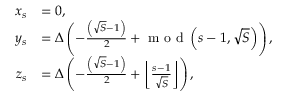<formula> <loc_0><loc_0><loc_500><loc_500>\begin{array} { r l } { x _ { s } } & { = 0 , } \\ { y _ { s } } & { = \Delta \left ( - \frac { \left ( \sqrt { S } - 1 \right ) } { 2 } + m o d \left ( s - 1 , \sqrt { S } \right ) \right ) , } \\ { z _ { s } } & { = \Delta \left ( - \frac { \left ( \sqrt { S } - 1 \right ) } { 2 } + \left \lfloor \frac { s - 1 } { \sqrt { S } } \right \rfloor \right ) , } \end{array}</formula> 